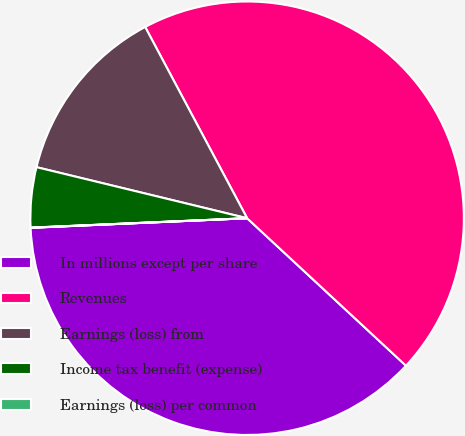<chart> <loc_0><loc_0><loc_500><loc_500><pie_chart><fcel>In millions except per share<fcel>Revenues<fcel>Earnings (loss) from<fcel>Income tax benefit (expense)<fcel>Earnings (loss) per common<nl><fcel>37.39%<fcel>44.71%<fcel>13.42%<fcel>4.48%<fcel>0.01%<nl></chart> 